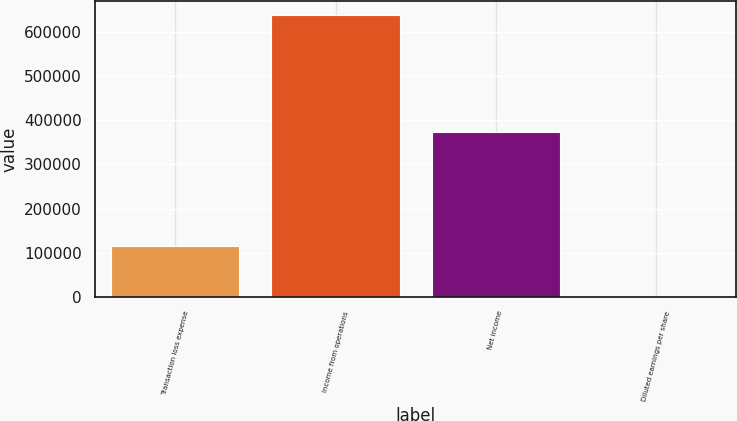<chart> <loc_0><loc_0><loc_500><loc_500><bar_chart><fcel>Transaction loss expense<fcel>Income from operations<fcel>Net income<fcel>Diluted earnings per share<nl><fcel>115520<fcel>636915<fcel>371986<fcel>0.27<nl></chart> 